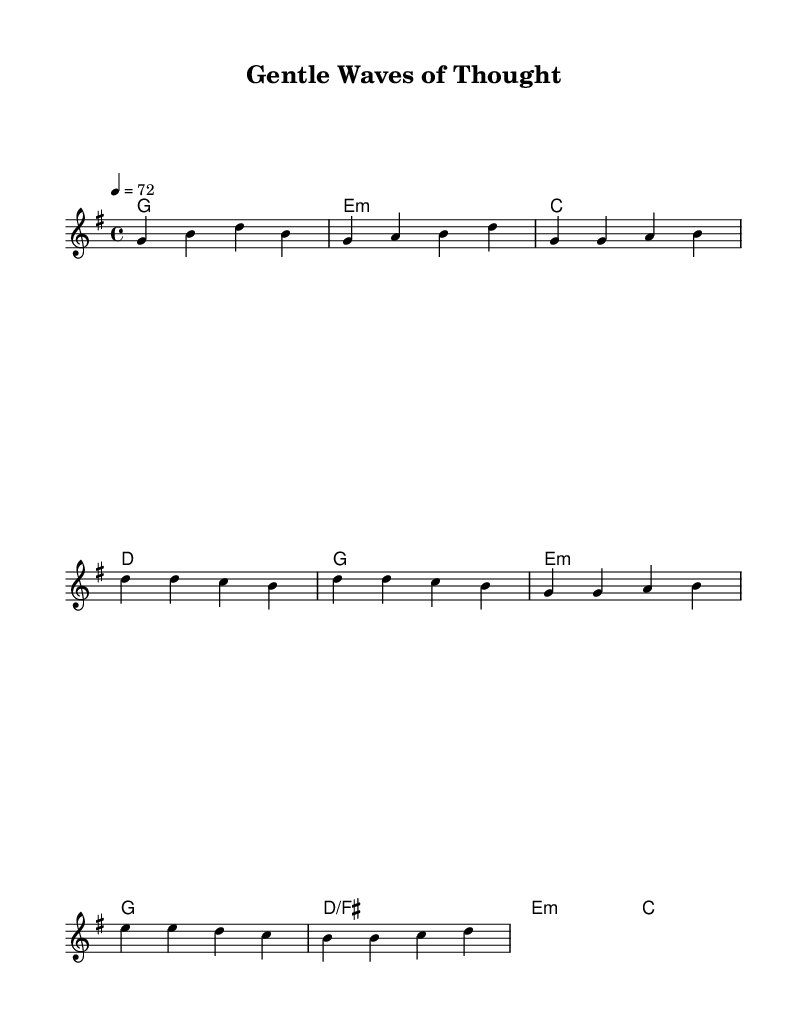What is the key signature of this music? The key signature indicates G major, which has one sharp (F#). This can be observed at the beginning of the sheet music, where the sharp is indicated.
Answer: G major What is the time signature of this piece? The time signature is 4/4, which can be identified at the start of the music. This indicates that there are four beats in each measure, with a quarter note receiving one beat.
Answer: 4/4 What is the tempo marking for this sheet music? The tempo is marked as 4 = 72. This means that the piece should be played at 72 beats per minute, and the number is a reference indicating how many quarter note beats should occur in one minute.
Answer: 72 How many measures does the melody cover in the provided excerpt? By counting the groups of notes from the introduction, verse, chorus, and bridge, one can determine that there are a total of eight measures shown in the melody. The measures are grouped and separated throughout the sheet music.
Answer: 8 What is the primary chord progression in the verse? The verse features a chord progression primarily based around G and E minor. By looking at the chord names placed above the melody notes, we can see that these are the main chords listed in the verse section.
Answer: G, E minor Is there a bridge section in this music? Yes, there is a bridge section indicated, specifically labeled as "Bridge" in the melody. This part has its own distinct melody and harmonic structure that contrasts with the verses and chorus, which can be identified by the provided labels in the sheet music.
Answer: Yes 